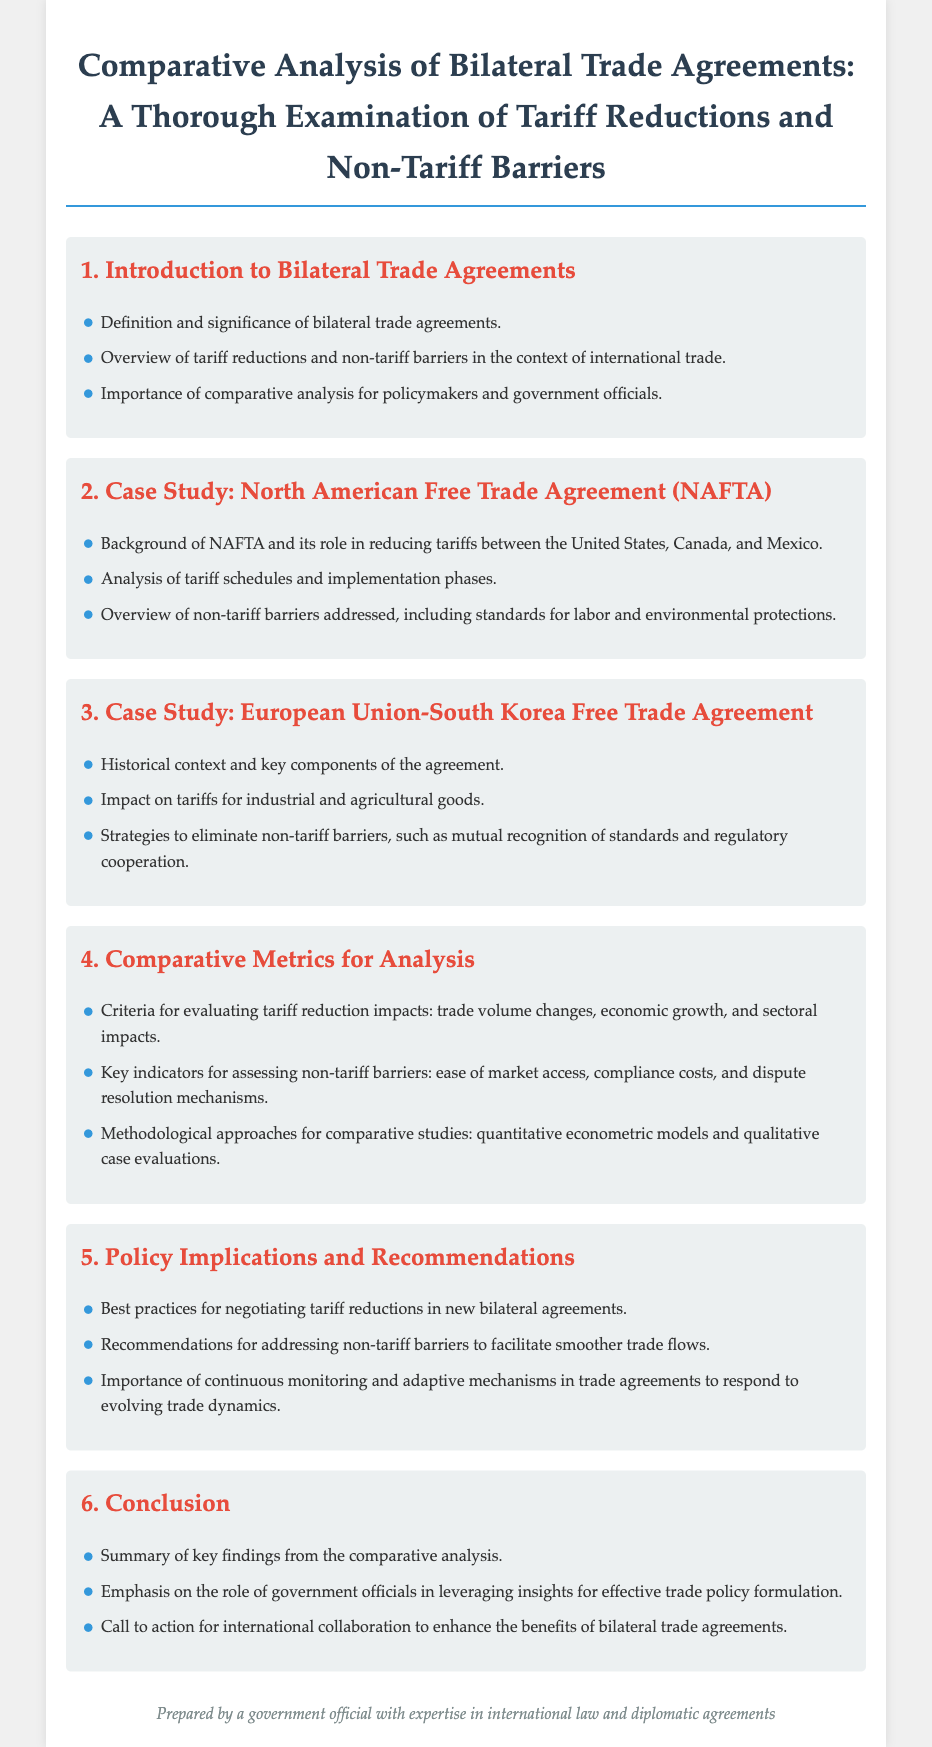What is the first section of the document? The first section introduced in the document is concerned with bilateral trade agreements and their significance.
Answer: Introduction to Bilateral Trade Agreements What does NAFTA stand for? The document mentions NAFTA as the abbreviation for the North American Free Trade Agreement.
Answer: North American Free Trade Agreement What are the key components addressed in the European Union-South Korea Free Trade Agreement? The document lists impact on tariffs and strategies to eliminate non-tariff barriers as key components.
Answer: Impact on tariffs for industrial and agricultural goods What are the criteria for evaluating tariff reduction impacts? The document specifies that trade volume changes, economic growth, and sectoral impacts are the criteria for evaluation.
Answer: Trade volume changes, economic growth, and sectoral impacts What is one recommendation for addressing non-tariff barriers? The document recommends addressing non-tariff barriers to facilitate smoother trade flows.
Answer: Addressing non-tariff barriers What is the total number of sections in the document? The document contains six sections in total.
Answer: Six 